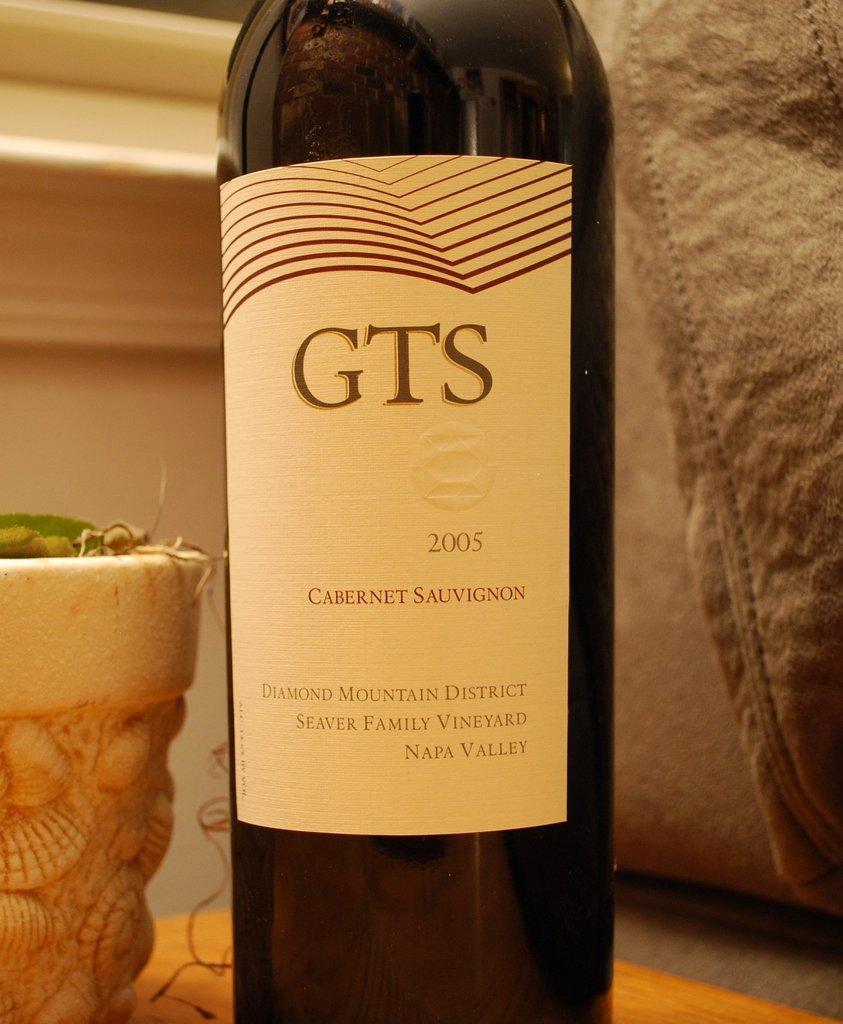What year is inscribed on that bottle?
Offer a terse response. 2005. 